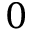<formula> <loc_0><loc_0><loc_500><loc_500>0</formula> 